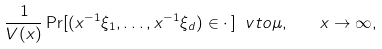<formula> <loc_0><loc_0><loc_500><loc_500>\frac { 1 } { V ( x ) } \Pr [ ( x ^ { - 1 } \xi _ { 1 } , \dots , x ^ { - 1 } \xi _ { d } ) \in \cdot \, ] \ v t o \mu , \quad x \to \infty ,</formula> 